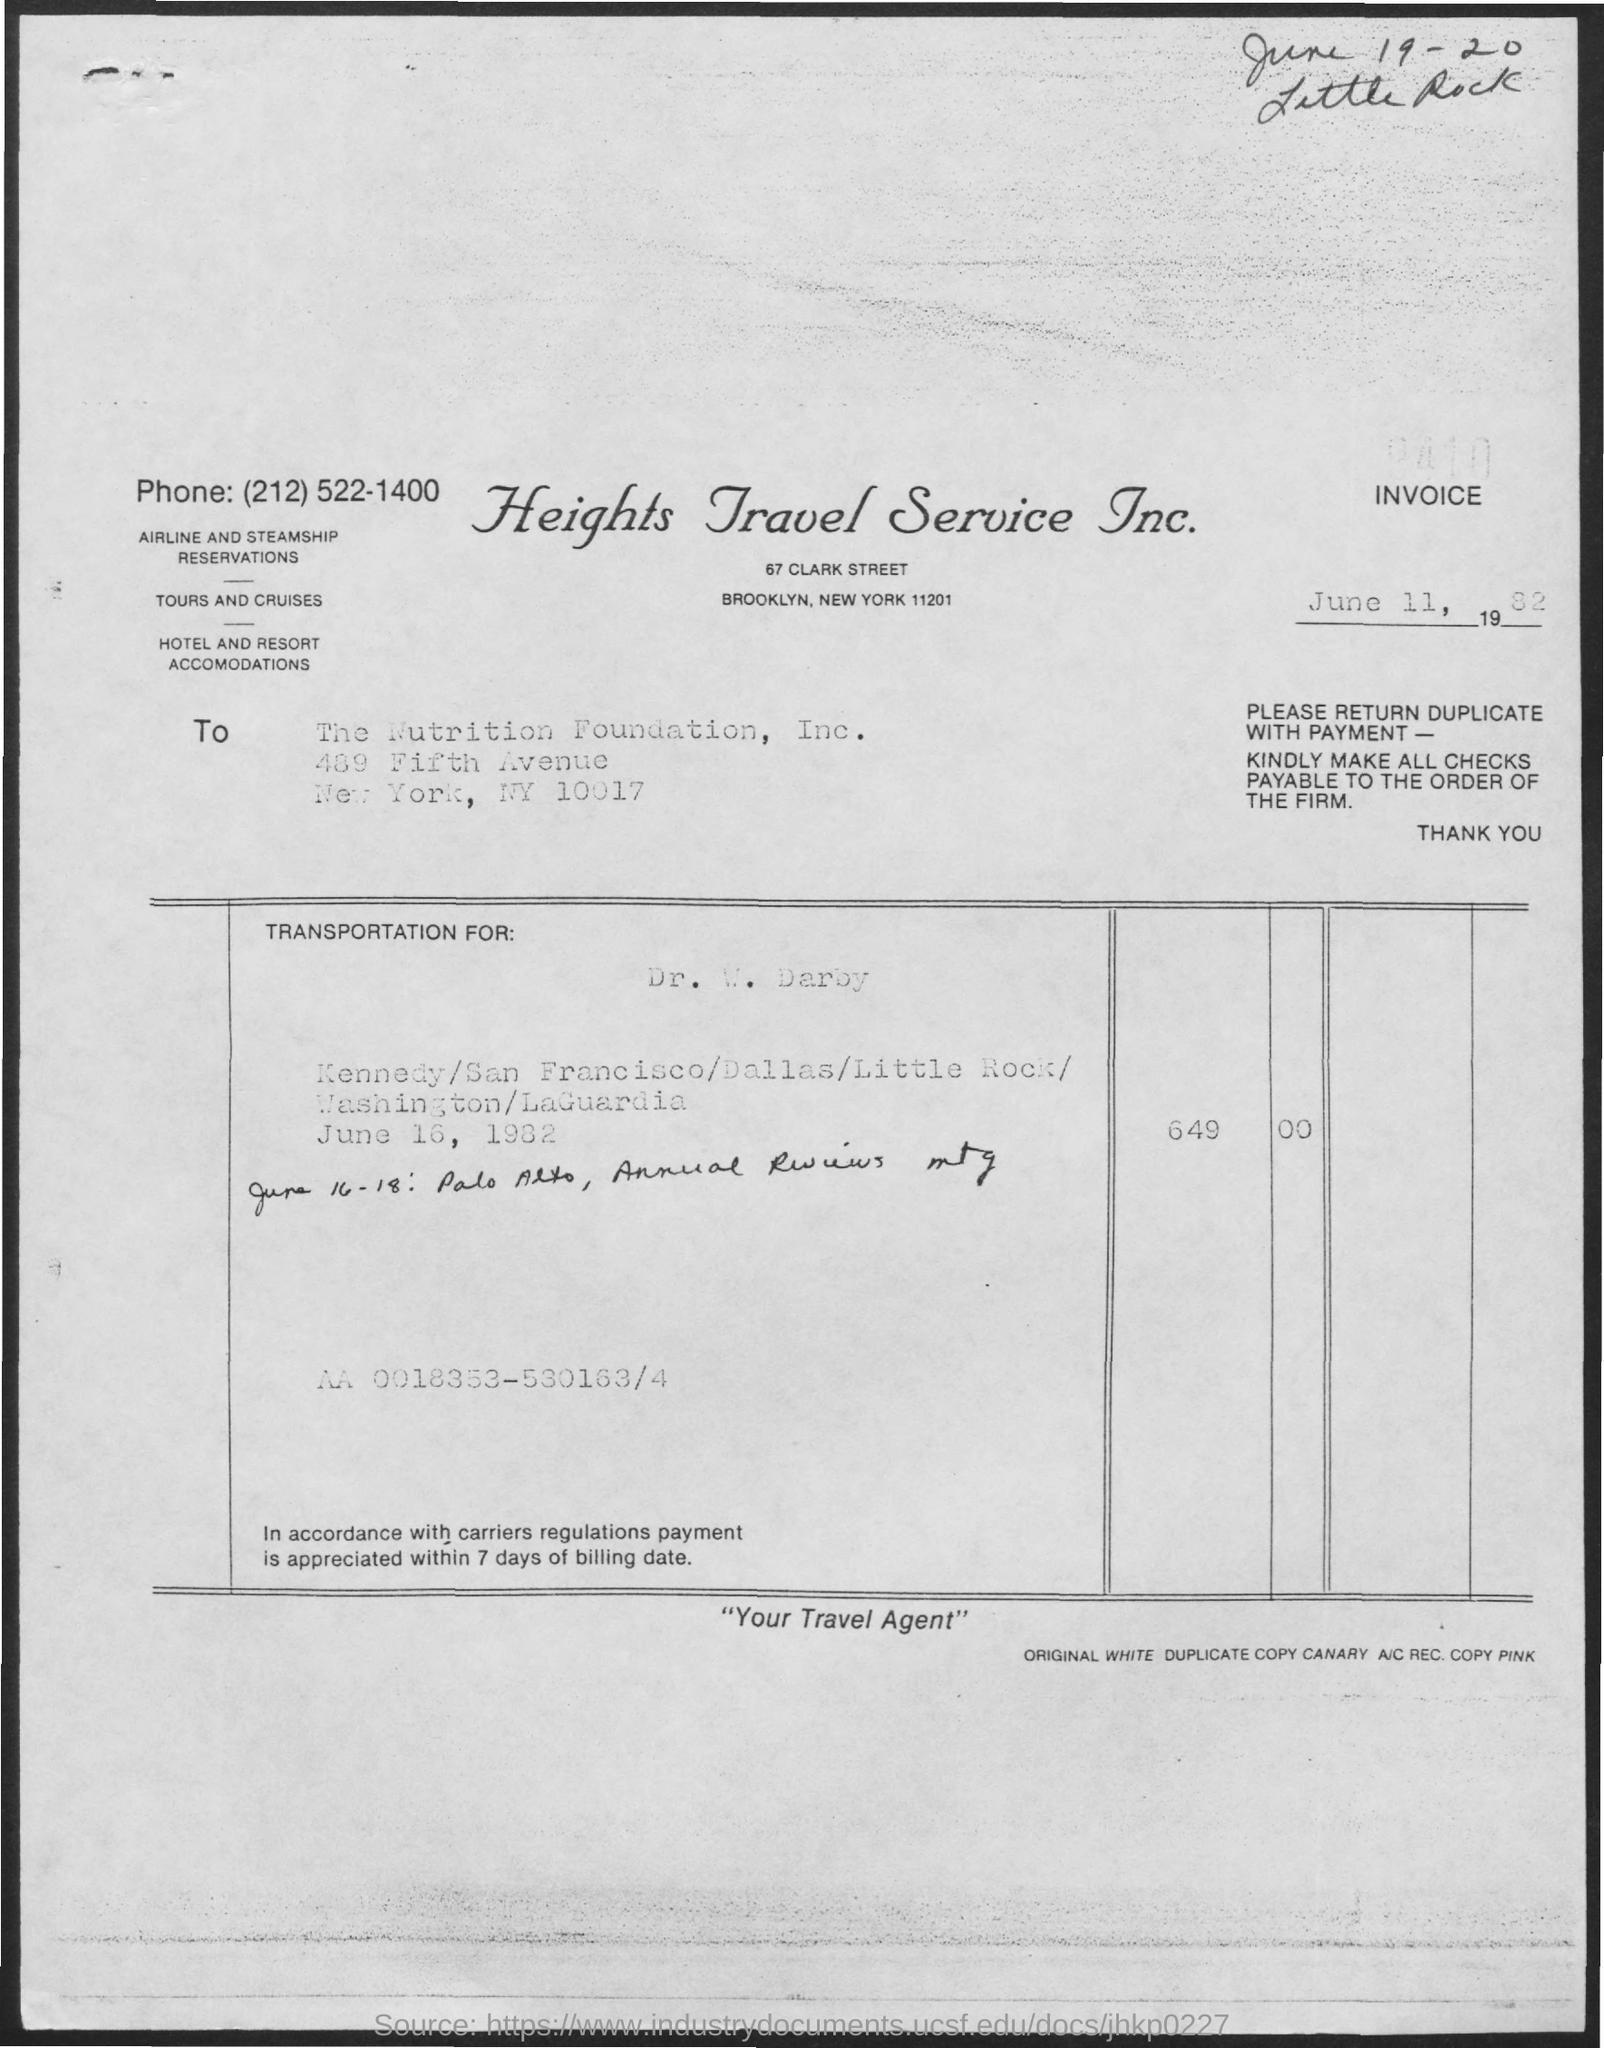What is the name of the travel service?
Offer a terse response. Heights Travel Service Inc. 